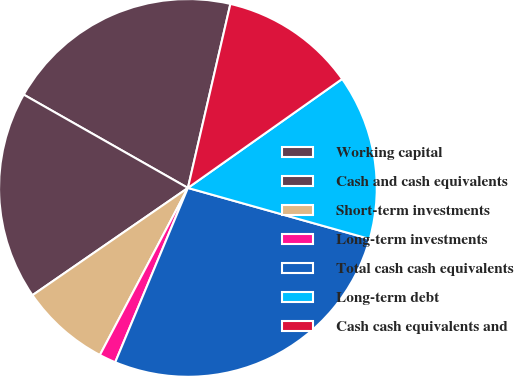Convert chart. <chart><loc_0><loc_0><loc_500><loc_500><pie_chart><fcel>Working capital<fcel>Cash and cash equivalents<fcel>Short-term investments<fcel>Long-term investments<fcel>Total cash cash equivalents<fcel>Long-term debt<fcel>Cash cash equivalents and<nl><fcel>20.39%<fcel>17.84%<fcel>7.67%<fcel>1.43%<fcel>26.93%<fcel>14.15%<fcel>11.6%<nl></chart> 